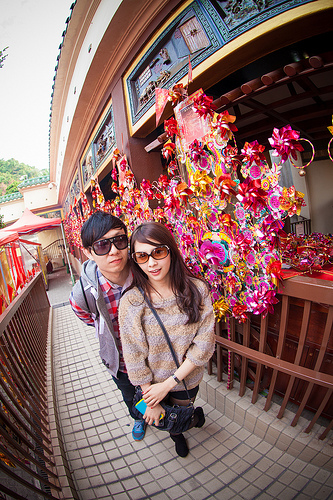<image>
Can you confirm if the woman is on the man? No. The woman is not positioned on the man. They may be near each other, but the woman is not supported by or resting on top of the man. Where is the woman in relation to the man? Is it behind the man? No. The woman is not behind the man. From this viewpoint, the woman appears to be positioned elsewhere in the scene. Is the girl next to the paperwork? Yes. The girl is positioned adjacent to the paperwork, located nearby in the same general area. 